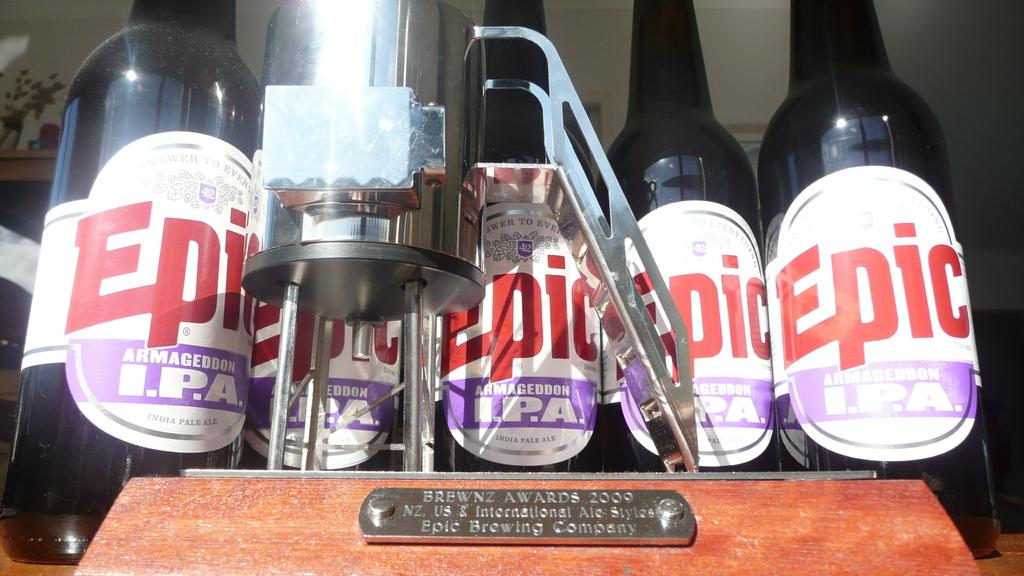<image>
Create a compact narrative representing the image presented. A Brewnz Award from 2000 surrounded by Epic Armageddon I.P.A. 